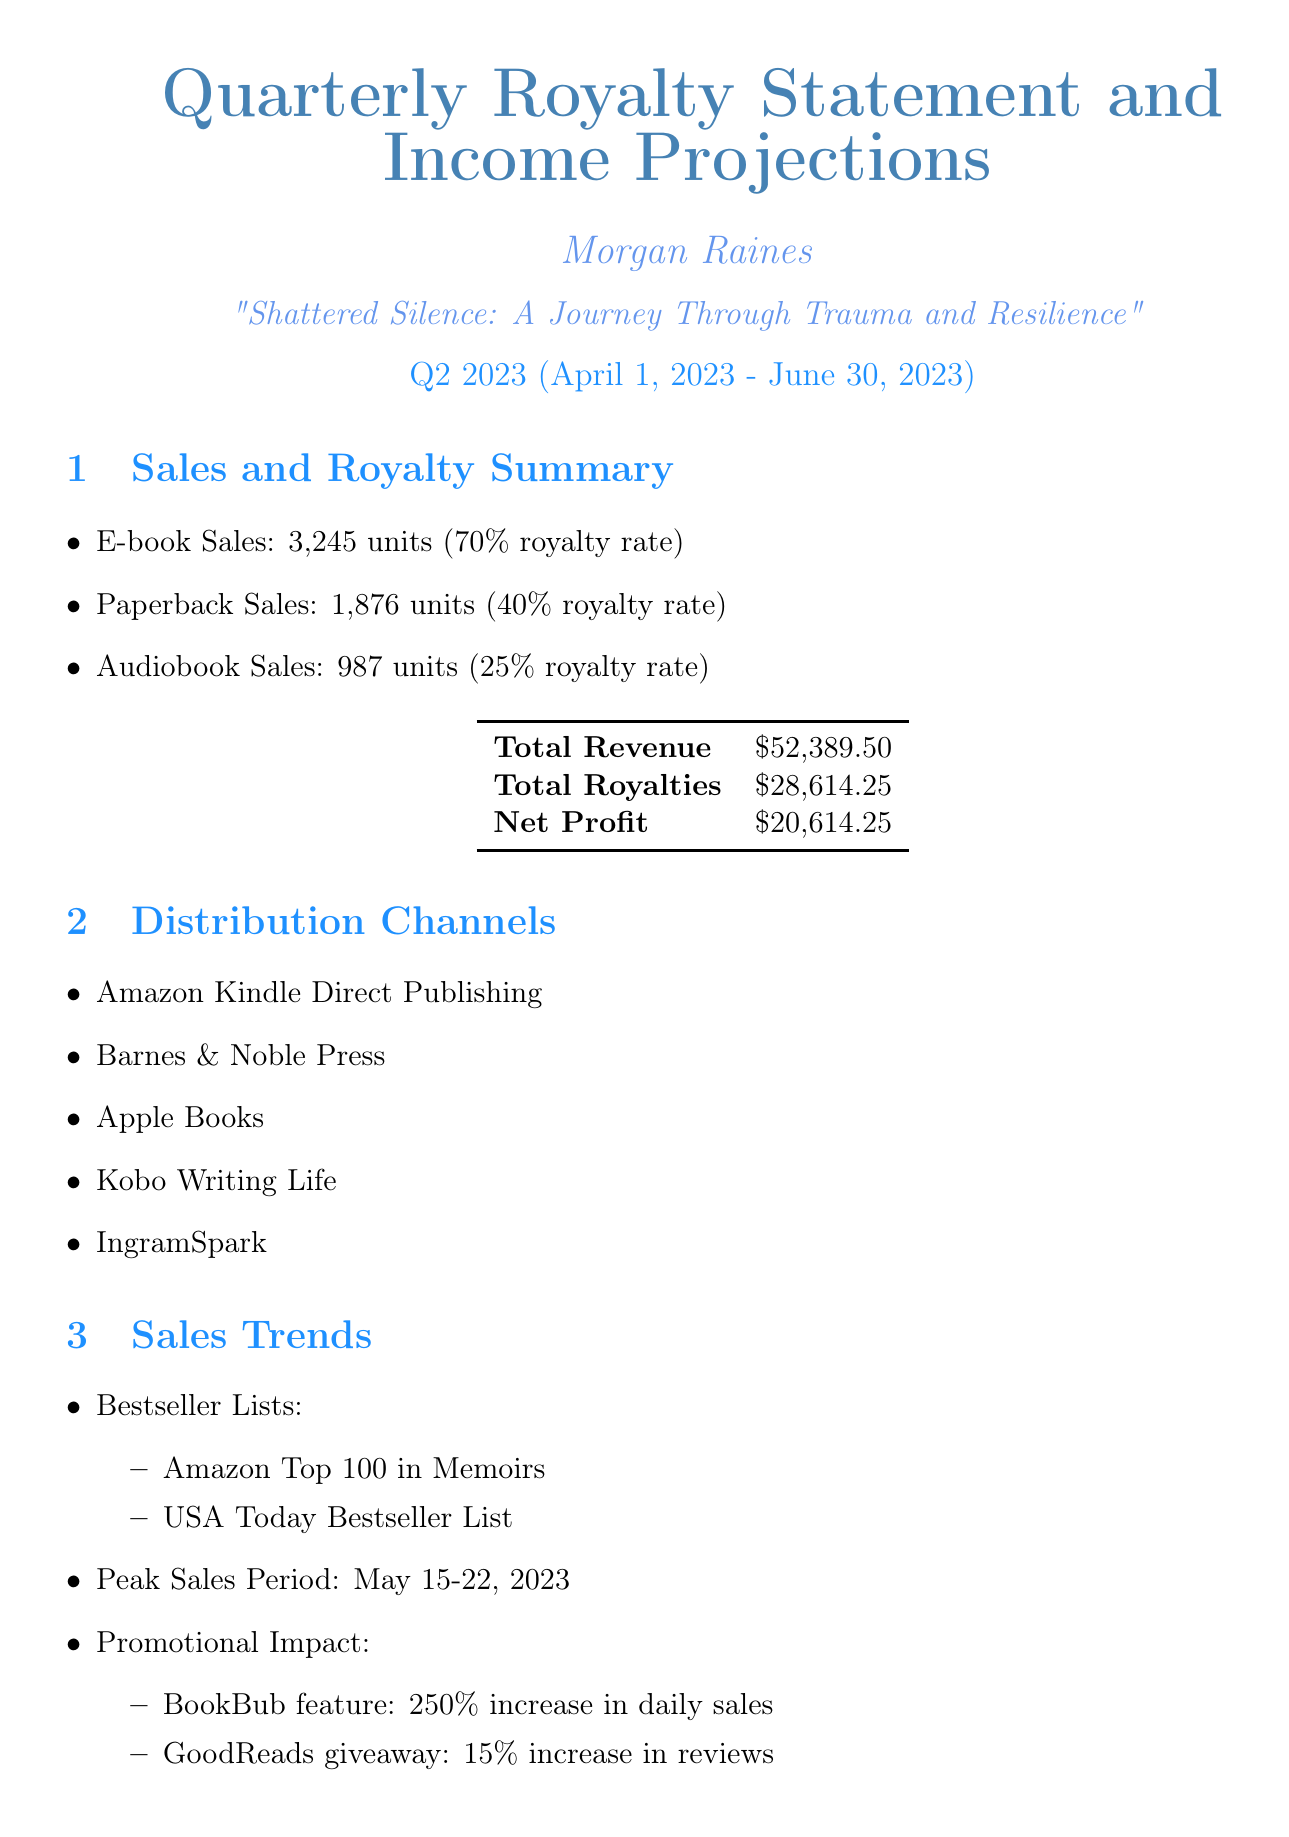What is the total revenue? The total revenue is provided in the financial summary section of the document, which states the total revenue is $52,389.50.
Answer: $52,389.50 What is the average rating of the book? The reader engagement section indicates the average rating of the book is 4.7 stars.
Answer: 4.7 What was the peak sales period? The sales trends section specifies that the peak sales period is from May 15-22, 2023.
Answer: May 15-22, 2023 What is the percentage increase in daily sales due to the BookBub feature? The promotional impact mentioned in the sales trends section indicates a 250% increase in daily sales due to the BookBub feature.
Answer: 250% How many units of audiobooks were sold? The sales breakdown section indicates that 987 audiobooks were sold.
Answer: 987 What are the planned activities in marketing strategies? The document lists planned marketing activities, which include TED Talk submission, literary festival participation, and mental health awareness campaign tie-in.
Answer: TED Talk submission, literary festival participation, mental health awareness campaign tie-in What is the total net profit? The financial summary specifically states that the net profit is $20,614.25.
Answer: $20,614.25 What is the next quarter income estimate? The income projection section estimates the next quarter's income to be $32,000.
Answer: $32,000 What are the potential adaptations mentioned for the book? The future opportunities section highlights potential adaptations, including a Netflix documentary series and a theatrical play.
Answer: Netflix documentary series, theatrical play 